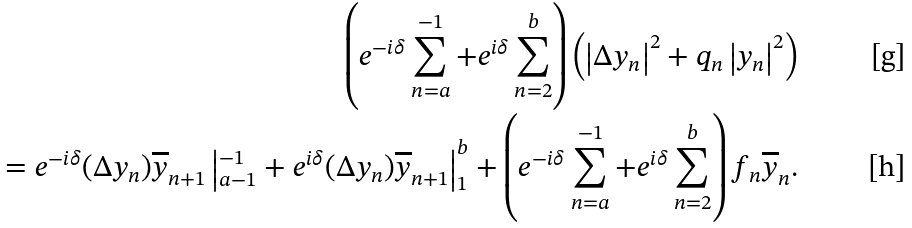Convert formula to latex. <formula><loc_0><loc_0><loc_500><loc_500>\left ( e ^ { - i \delta } \sum _ { n = a } ^ { - 1 } + e ^ { i \delta } \sum _ { n = 2 } ^ { b } \right ) \left ( \left | \Delta y _ { n } \right | ^ { 2 } + q _ { n } \left | y _ { n } \right | ^ { 2 } \right ) \\ \quad = e ^ { - i \delta } ( \Delta y _ { n } ) \overline { y } _ { n + 1 } \left | _ { a - 1 } ^ { - 1 } + e ^ { i \delta } ( \Delta y _ { n } ) \overline { y } _ { n + 1 } \right | _ { 1 } ^ { b } + \left ( e ^ { - i \delta } \sum _ { n = a } ^ { - 1 } + e ^ { i \delta } \sum _ { n = 2 } ^ { b } \right ) f _ { n } \overline { y } _ { n } .</formula> 